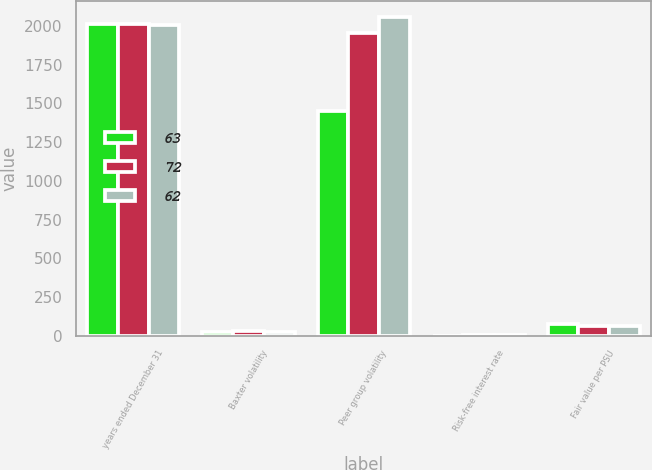Convert chart. <chart><loc_0><loc_0><loc_500><loc_500><stacked_bar_chart><ecel><fcel>years ended December 31<fcel>Baxter volatility<fcel>Peer group volatility<fcel>Risk-free interest rate<fcel>Fair value per PSU<nl><fcel>63<fcel>2012<fcel>24<fcel>1450<fcel>0.4<fcel>72<nl><fcel>72<fcel>2011<fcel>28<fcel>1955<fcel>1.2<fcel>62<nl><fcel>62<fcel>2010<fcel>26<fcel>2059<fcel>1.3<fcel>63<nl></chart> 